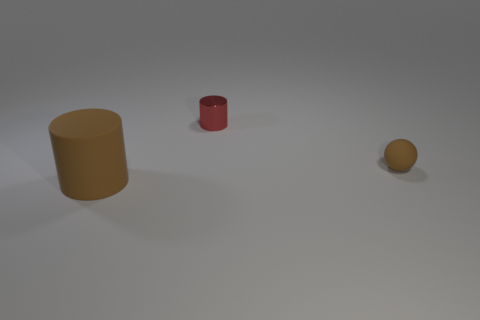There is a small rubber object that is the same color as the big cylinder; what shape is it?
Make the answer very short. Sphere. There is a object that is in front of the red cylinder and to the left of the brown ball; what material is it made of?
Your response must be concise. Rubber. What is the size of the ball that is the same color as the rubber cylinder?
Ensure brevity in your answer.  Small. What number of other objects are there of the same size as the brown rubber cylinder?
Keep it short and to the point. 0. There is a thing to the left of the small red metal cylinder; what is its material?
Your answer should be very brief. Rubber. Does the large brown object have the same shape as the tiny red thing?
Provide a succinct answer. Yes. What number of other objects are the same shape as the large brown thing?
Keep it short and to the point. 1. What color is the cylinder to the left of the metallic object?
Give a very brief answer. Brown. Do the metallic cylinder and the brown sphere have the same size?
Your answer should be very brief. Yes. What is the material of the tiny object right of the cylinder that is behind the small brown object?
Make the answer very short. Rubber. 